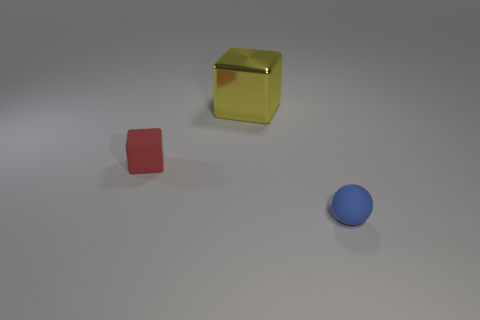Add 2 purple metal blocks. How many objects exist? 5 Subtract all cubes. How many objects are left? 1 Subtract all blue shiny objects. Subtract all large yellow blocks. How many objects are left? 2 Add 1 tiny cubes. How many tiny cubes are left? 2 Add 3 large yellow metallic objects. How many large yellow metallic objects exist? 4 Subtract 1 red blocks. How many objects are left? 2 